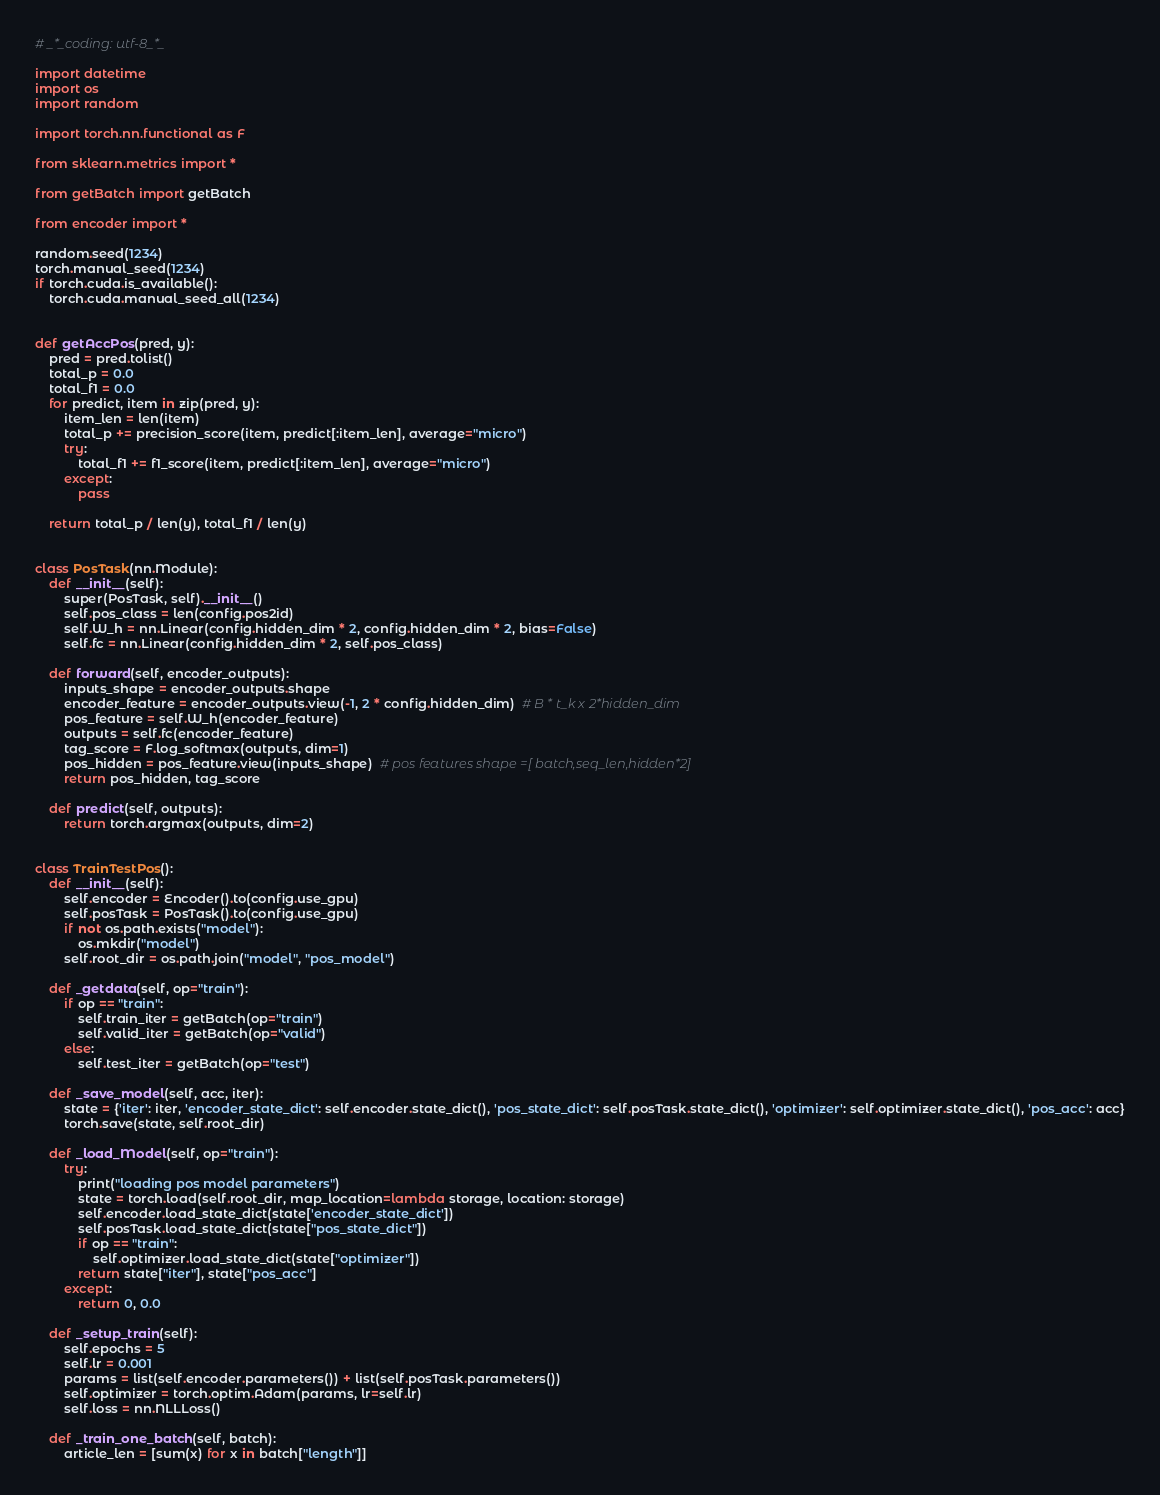Convert code to text. <code><loc_0><loc_0><loc_500><loc_500><_Python_># _*_coding: utf-8_*_

import datetime
import os
import random

import torch.nn.functional as F

from sklearn.metrics import *

from getBatch import getBatch

from encoder import *

random.seed(1234)
torch.manual_seed(1234)
if torch.cuda.is_available():
    torch.cuda.manual_seed_all(1234)


def getAccPos(pred, y):
    pred = pred.tolist()
    total_p = 0.0
    total_f1 = 0.0
    for predict, item in zip(pred, y):
        item_len = len(item)
        total_p += precision_score(item, predict[:item_len], average="micro")
        try:
            total_f1 += f1_score(item, predict[:item_len], average="micro")
        except:
            pass

    return total_p / len(y), total_f1 / len(y)


class PosTask(nn.Module):
    def __init__(self):
        super(PosTask, self).__init__()
        self.pos_class = len(config.pos2id)
        self.W_h = nn.Linear(config.hidden_dim * 2, config.hidden_dim * 2, bias=False)
        self.fc = nn.Linear(config.hidden_dim * 2, self.pos_class)

    def forward(self, encoder_outputs):
        inputs_shape = encoder_outputs.shape
        encoder_feature = encoder_outputs.view(-1, 2 * config.hidden_dim)  # B * t_k x 2*hidden_dim
        pos_feature = self.W_h(encoder_feature)
        outputs = self.fc(encoder_feature)
        tag_score = F.log_softmax(outputs, dim=1)
        pos_hidden = pos_feature.view(inputs_shape)  # pos features shape =[ batch,seq_len,hidden*2]
        return pos_hidden, tag_score

    def predict(self, outputs):
        return torch.argmax(outputs, dim=2)


class TrainTestPos():
    def __init__(self):
        self.encoder = Encoder().to(config.use_gpu)
        self.posTask = PosTask().to(config.use_gpu)
        if not os.path.exists("model"):
            os.mkdir("model")
        self.root_dir = os.path.join("model", "pos_model")

    def _getdata(self, op="train"):
        if op == "train":
            self.train_iter = getBatch(op="train")
            self.valid_iter = getBatch(op="valid")
        else:
            self.test_iter = getBatch(op="test")

    def _save_model(self, acc, iter):
        state = {'iter': iter, 'encoder_state_dict': self.encoder.state_dict(), 'pos_state_dict': self.posTask.state_dict(), 'optimizer': self.optimizer.state_dict(), 'pos_acc': acc}
        torch.save(state, self.root_dir)

    def _load_Model(self, op="train"):
        try:
            print("loading pos model parameters")
            state = torch.load(self.root_dir, map_location=lambda storage, location: storage)
            self.encoder.load_state_dict(state['encoder_state_dict'])
            self.posTask.load_state_dict(state["pos_state_dict"])
            if op == "train":
                self.optimizer.load_state_dict(state["optimizer"])
            return state["iter"], state["pos_acc"]
        except:
            return 0, 0.0

    def _setup_train(self):
        self.epochs = 5
        self.lr = 0.001
        params = list(self.encoder.parameters()) + list(self.posTask.parameters())
        self.optimizer = torch.optim.Adam(params, lr=self.lr)
        self.loss = nn.NLLLoss()

    def _train_one_batch(self, batch):
        article_len = [sum(x) for x in batch["length"]]</code> 